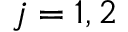Convert formula to latex. <formula><loc_0><loc_0><loc_500><loc_500>j = 1 , 2</formula> 